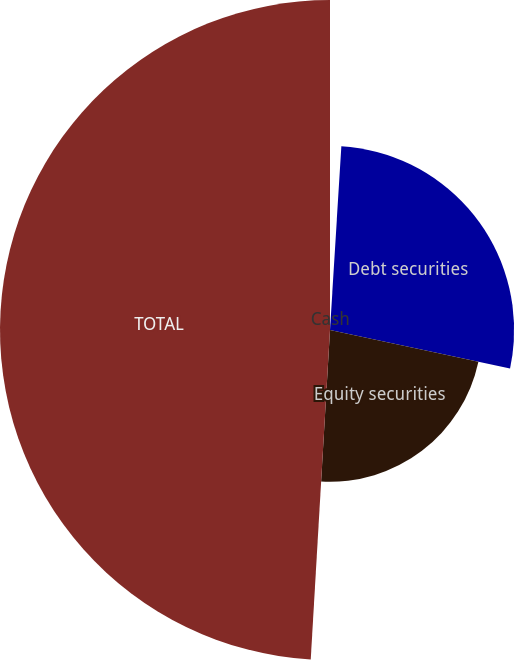<chart> <loc_0><loc_0><loc_500><loc_500><pie_chart><fcel>Cash<fcel>Debt securities<fcel>Equity securities<fcel>TOTAL<nl><fcel>0.98%<fcel>27.38%<fcel>22.57%<fcel>49.07%<nl></chart> 